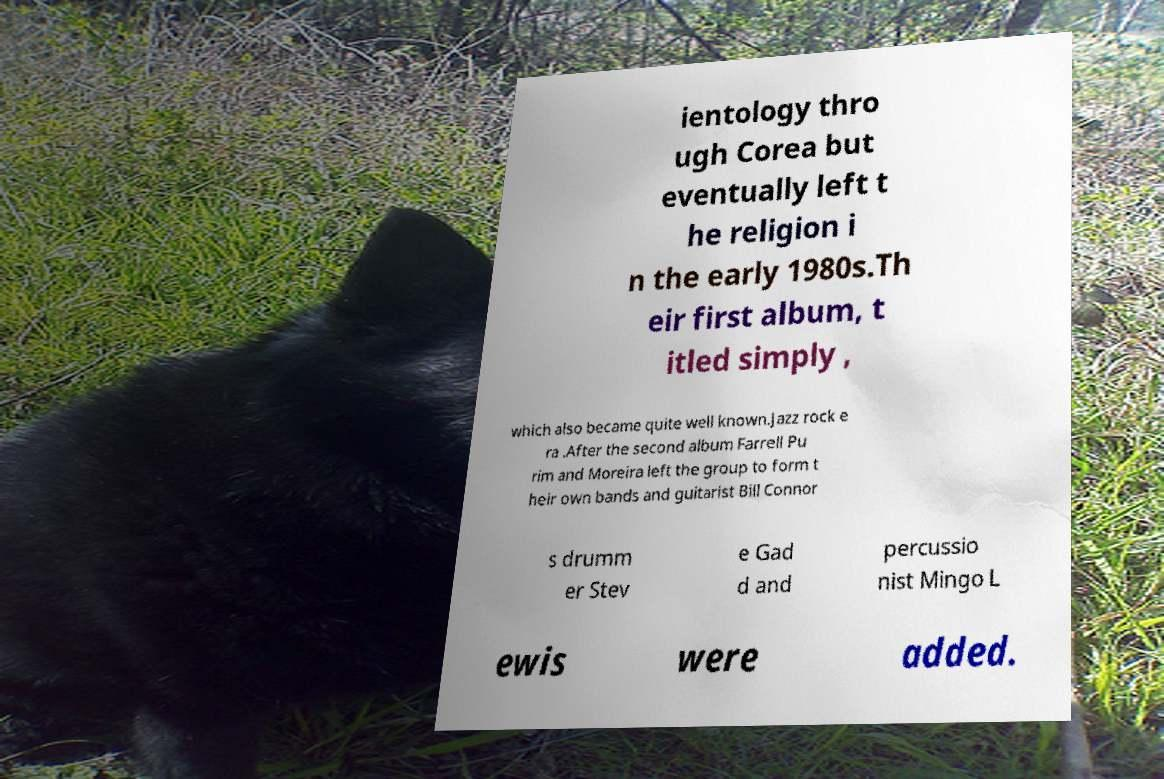Could you extract and type out the text from this image? ientology thro ugh Corea but eventually left t he religion i n the early 1980s.Th eir first album, t itled simply , which also became quite well known.Jazz rock e ra .After the second album Farrell Pu rim and Moreira left the group to form t heir own bands and guitarist Bill Connor s drumm er Stev e Gad d and percussio nist Mingo L ewis were added. 